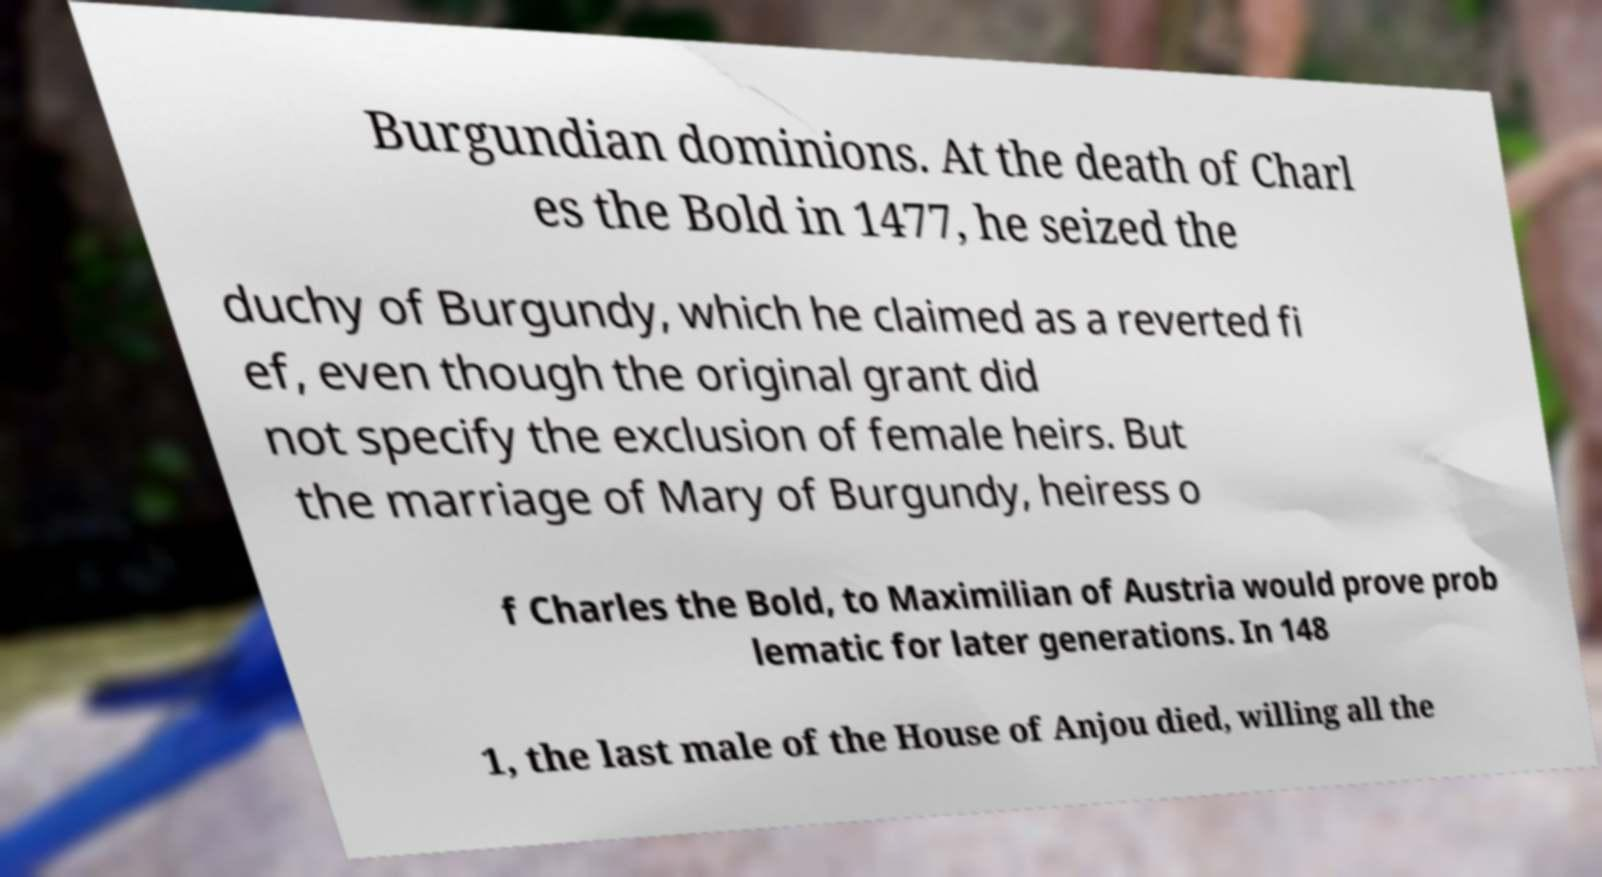Please identify and transcribe the text found in this image. Burgundian dominions. At the death of Charl es the Bold in 1477, he seized the duchy of Burgundy, which he claimed as a reverted fi ef, even though the original grant did not specify the exclusion of female heirs. But the marriage of Mary of Burgundy, heiress o f Charles the Bold, to Maximilian of Austria would prove prob lematic for later generations. In 148 1, the last male of the House of Anjou died, willing all the 